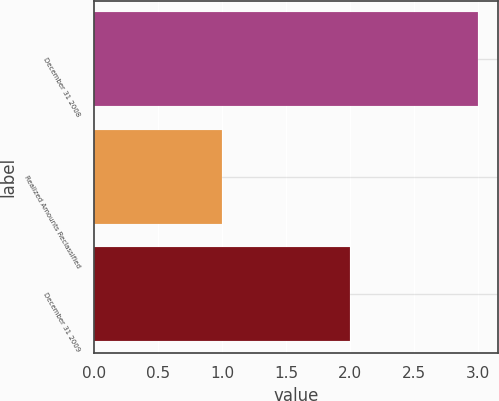Convert chart. <chart><loc_0><loc_0><loc_500><loc_500><bar_chart><fcel>December 31 2008<fcel>Realized Amounts Reclassified<fcel>December 31 2009<nl><fcel>3<fcel>1<fcel>2<nl></chart> 